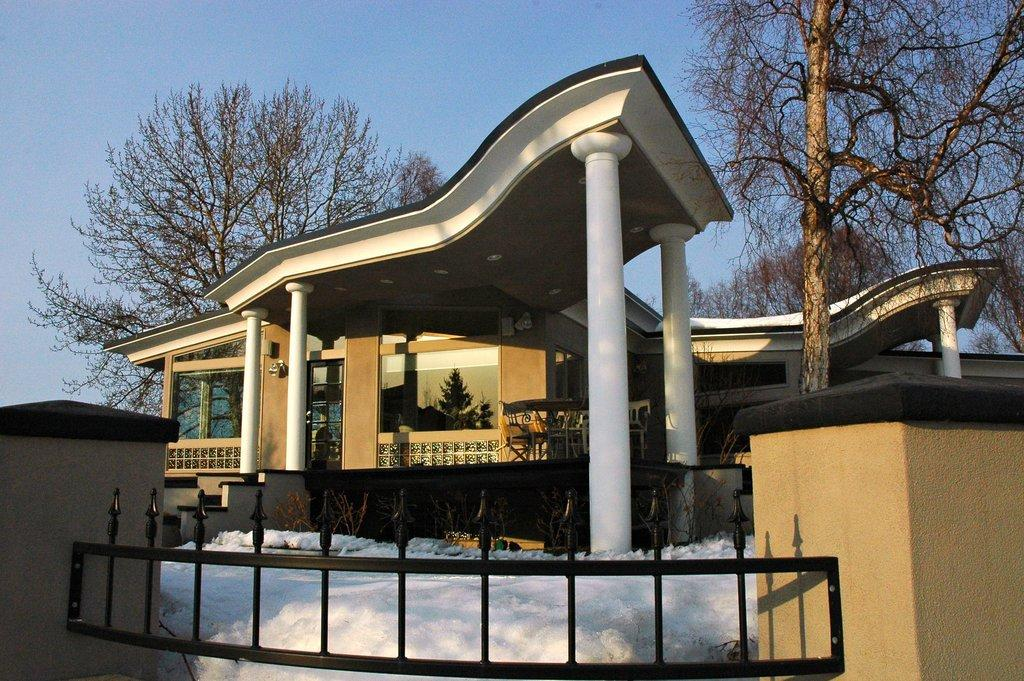What is located in the foreground of the image? In the foreground of the image, there is a fence, pillars, snow, pants, and a building. Can you describe the elements in the foreground of the image? The fence and pillars are made of a solid material, while the snow is a soft, white substance. The pants are a piece of clothing, and the building is a structure with walls and a roof. What can be seen in the background of the image? In the background of the image, there are trees and the sky. What is the time of day in the image? The image might have been taken during the day, as the sky is visible and there is no indication of darkness. What type of tail can be seen on the pants in the image? There is no tail present on the pants in the image. What time does the clock in the image show? There is no clock present in the image. How does the wind affect the snow in the image? The image does not show any indication of wind, so it cannot be determined how the wind might affect the snow. 